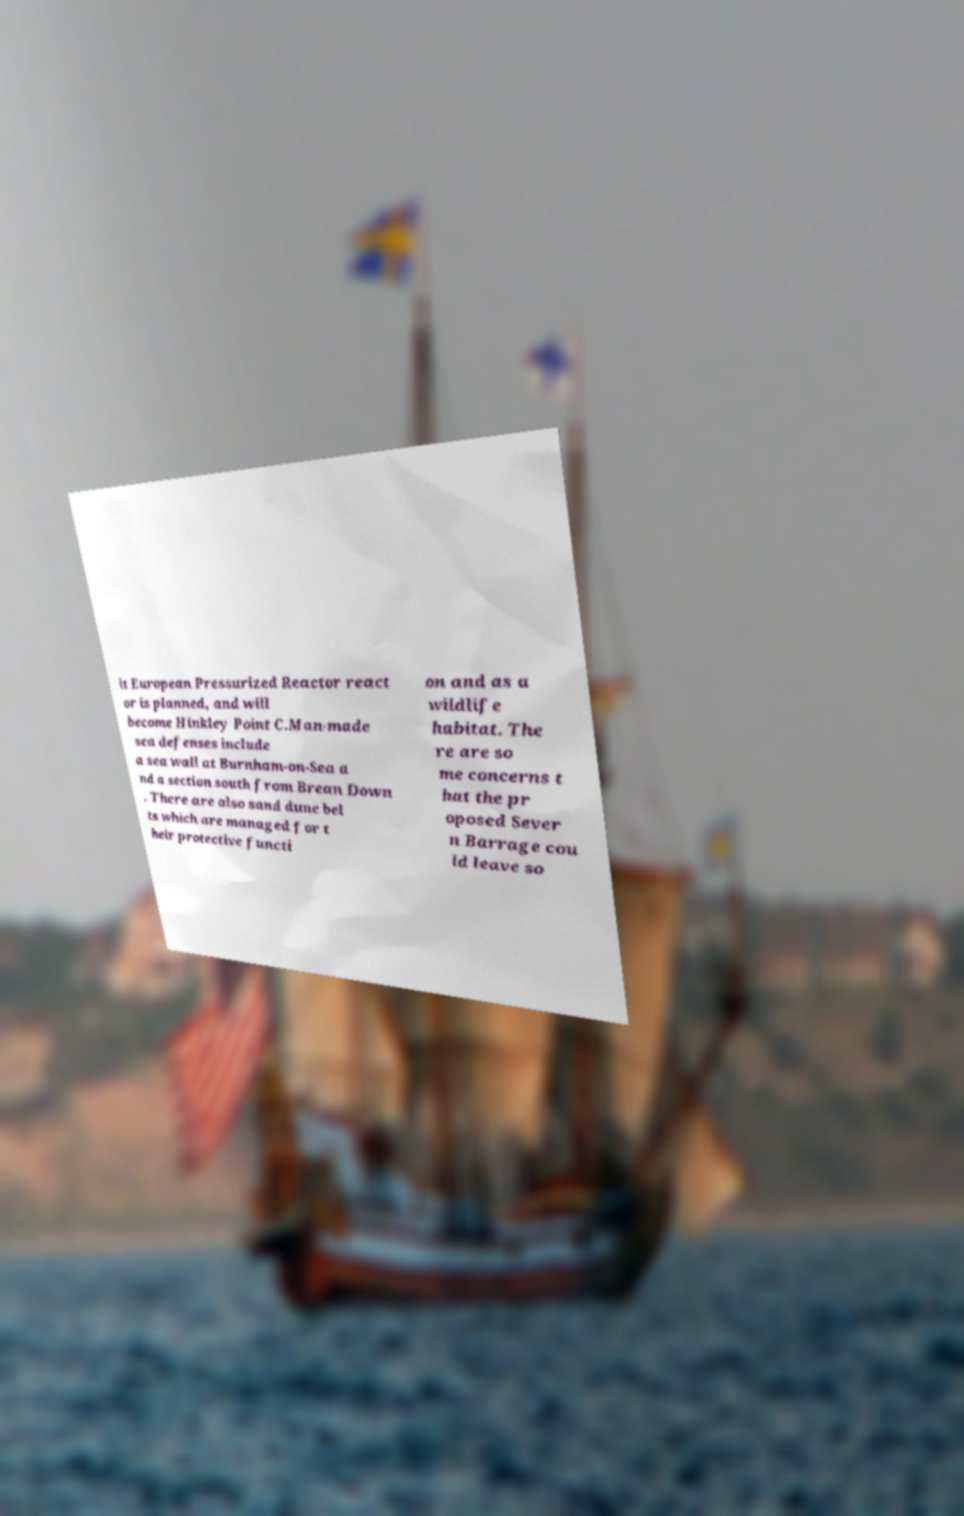What messages or text are displayed in this image? I need them in a readable, typed format. it European Pressurized Reactor react or is planned, and will become Hinkley Point C.Man-made sea defenses include a sea wall at Burnham-on-Sea a nd a section south from Brean Down . There are also sand dune bel ts which are managed for t heir protective functi on and as a wildlife habitat. The re are so me concerns t hat the pr oposed Sever n Barrage cou ld leave so 